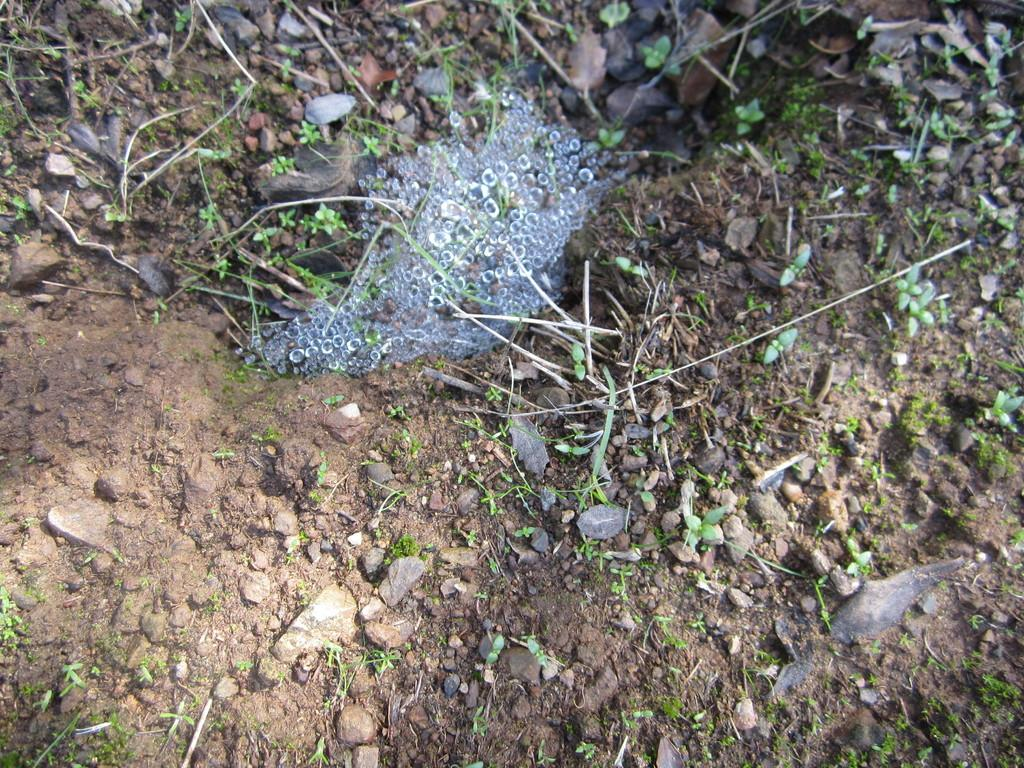What type of living organisms can be seen in the image? Plants are visible in the image. What other elements can be found in the image besides plants? There are stones and soil present in the image. What is located in the center of the image? There is water in the center of the image. What type of lace can be seen in the image? There is no lace present in the image. How comfortable are the plants in the image? The comfort of the plants cannot be determined from the image, as plants do not experience comfort in the same way humans do. 